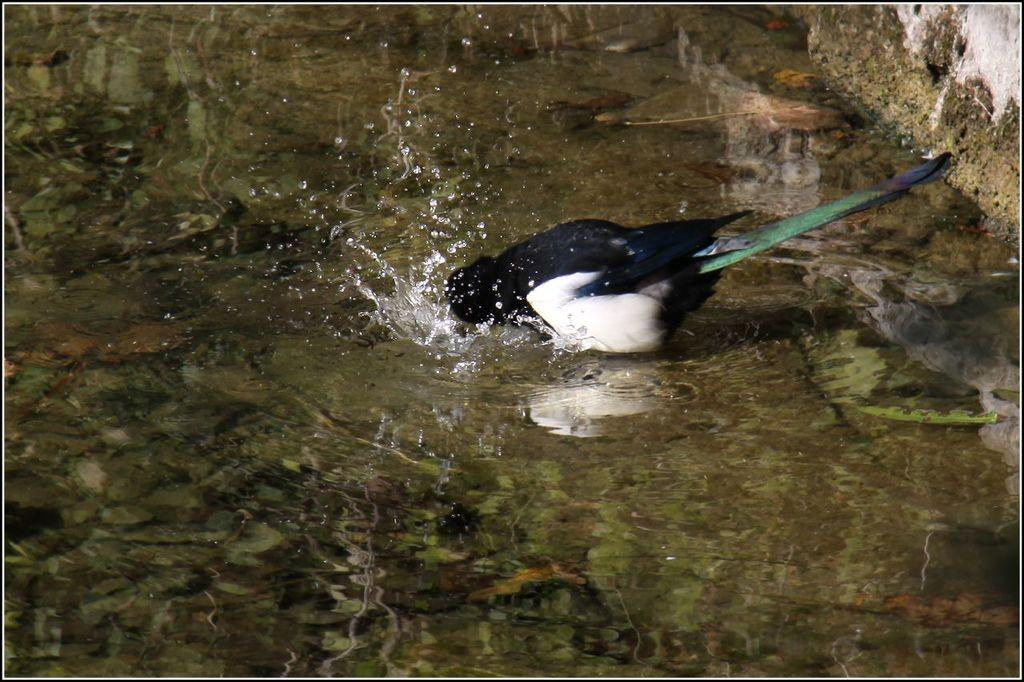What is in the water in the image? There is a bird in the water in the image. Can you describe any other elements in the image? There is a wall in the top right-hand corner of the image. How many sisters are participating in the competition in the image? There is no mention of sisters or a competition in the image. The image features a bird in the water and a wall in the top right-hand corner. 